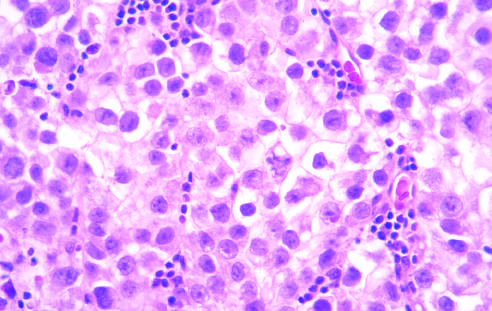what does microscopic examination reveal?
Answer the question using a single word or phrase. Large cells with distinct cell borders 